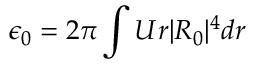<formula> <loc_0><loc_0><loc_500><loc_500>\epsilon _ { 0 } = 2 \pi \int U r | R _ { 0 } | ^ { 4 } d r</formula> 